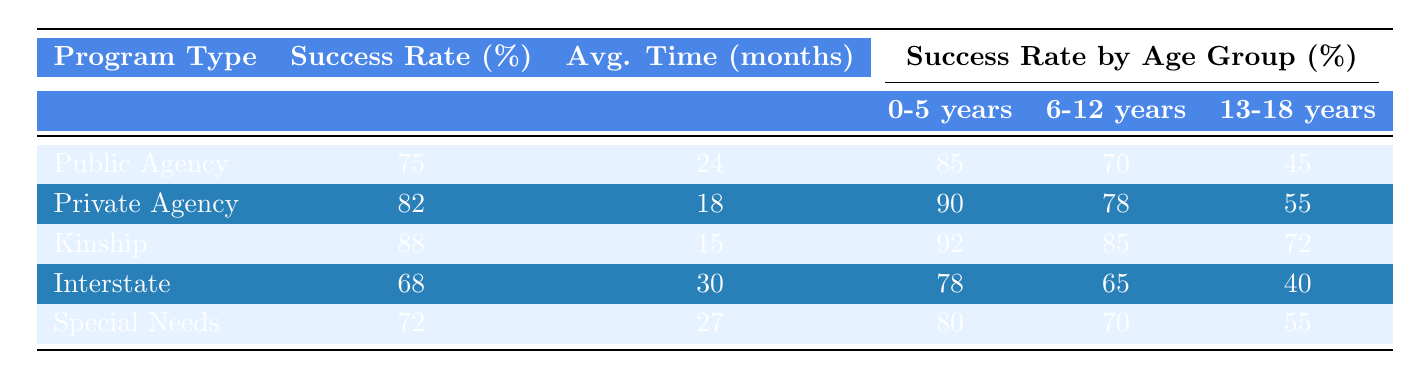What is the success rate for Kinship Adoptions? In the table under "Kinship Adoptions," the success rate is explicitly stated as 88%.
Answer: 88% Which program type has the lowest average time to adoption? The table indicates that "Kinship Adoptions" has the lowest average time to adoption at 15 months.
Answer: 15 months What is the success rate for 0-5 years age group in Private Agency Adoptions? In the Private Agency Adoptions section, the success rate for the 0-5 years age group is listed as 90%.
Answer: 90% How much lower is the success rate for 13-18 years in Public Agency Adoptions compared to Kinship Adoptions? The success rate for 13-18 years in Public Agency Adoptions is 45%, while for Kinship Adoptions it is 72%. The difference is 72 - 45 = 27%.
Answer: 27% Is the success rate for Special Needs Adoptions greater than that for Interstate Adoptions? The success rate for Special Needs Adoptions is 72%, and for Interstate Adoptions, it is 68%. Since 72% is greater than 68%, the statement is true.
Answer: Yes What is the average success rate for the 6-12 years age group across all program types? The success rates for the 6-12 years age group are: Public Agency (70%), Private Agency (78%), Kinship (85%), Interstate (65%), and Special Needs (70%). The average is (70 + 78 + 85 + 65 + 70) / 5 = 73.6%.
Answer: 73.6% Which program type has the highest overall success rate and what is it? The highest overall success rate in the table is for Kinship Adoptions at 88%.
Answer: 88% What difference in success rates exists between the 6-12 years age group and the 13-18 years age group for Private Agency Adoptions? For Private Agency Adoptions, the success rate for 6-12 years is 78%, while for 13-18 years it is 55%. The difference is 78 - 55 = 23%.
Answer: 23% Is the average time to adoption shorter for Private Agency Adoptions than for Special Needs Adoptions? Private Agency Adoptions has an average time to adoption of 18 months, while Special Needs Adoptions has 27 months. Since 18 is less than 27, the answer is true.
Answer: Yes What is the overall success rate of Foster Care to Adoption Programs (considering all types) if they are averaged? The overall success rates are: Public Agency (75%), Private Agency (82%), Kinship (88%), Interstate (68%), and Special Needs (72%). The average is (75 + 82 + 88 + 68 + 72) / 5 = 77%.
Answer: 77% 